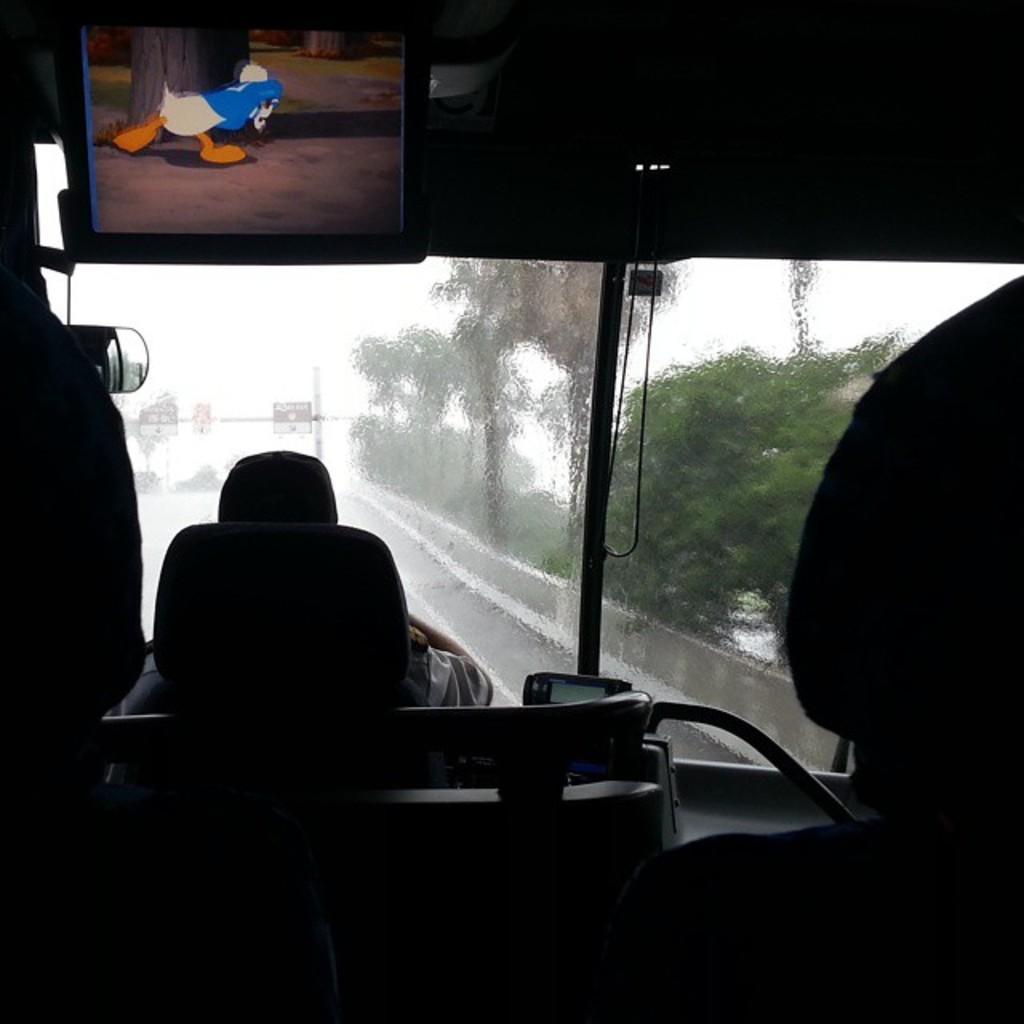How would you summarize this image in a sentence or two? This picture is taken inside of a vehicle. A screen is attached to the wall of a vehicle. There is a person sitting on the seat. From the window of the vehicle trees and sky are visible. There are boards attached to the pole. 